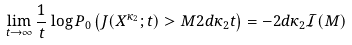Convert formula to latex. <formula><loc_0><loc_0><loc_500><loc_500>\lim _ { t \to \infty } \frac { 1 } { t } \log P _ { 0 } \left ( J ( X ^ { \kappa _ { 2 } } ; t ) > M 2 d \kappa _ { 2 } t \right ) = - 2 d \kappa _ { 2 } \mathcal { I } ( M )</formula> 